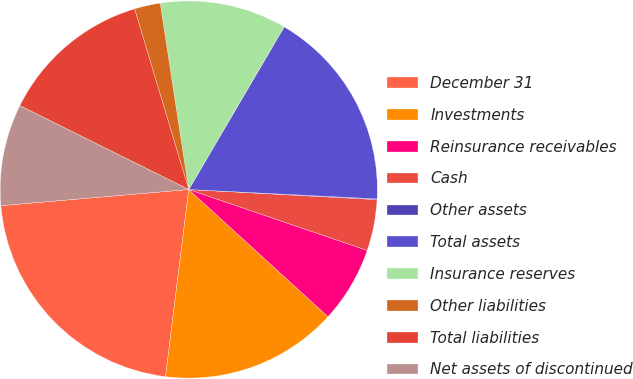Convert chart. <chart><loc_0><loc_0><loc_500><loc_500><pie_chart><fcel>December 31<fcel>Investments<fcel>Reinsurance receivables<fcel>Cash<fcel>Other assets<fcel>Total assets<fcel>Insurance reserves<fcel>Other liabilities<fcel>Total liabilities<fcel>Net assets of discontinued<nl><fcel>21.66%<fcel>15.18%<fcel>6.54%<fcel>4.38%<fcel>0.06%<fcel>17.34%<fcel>10.86%<fcel>2.22%<fcel>13.02%<fcel>8.7%<nl></chart> 